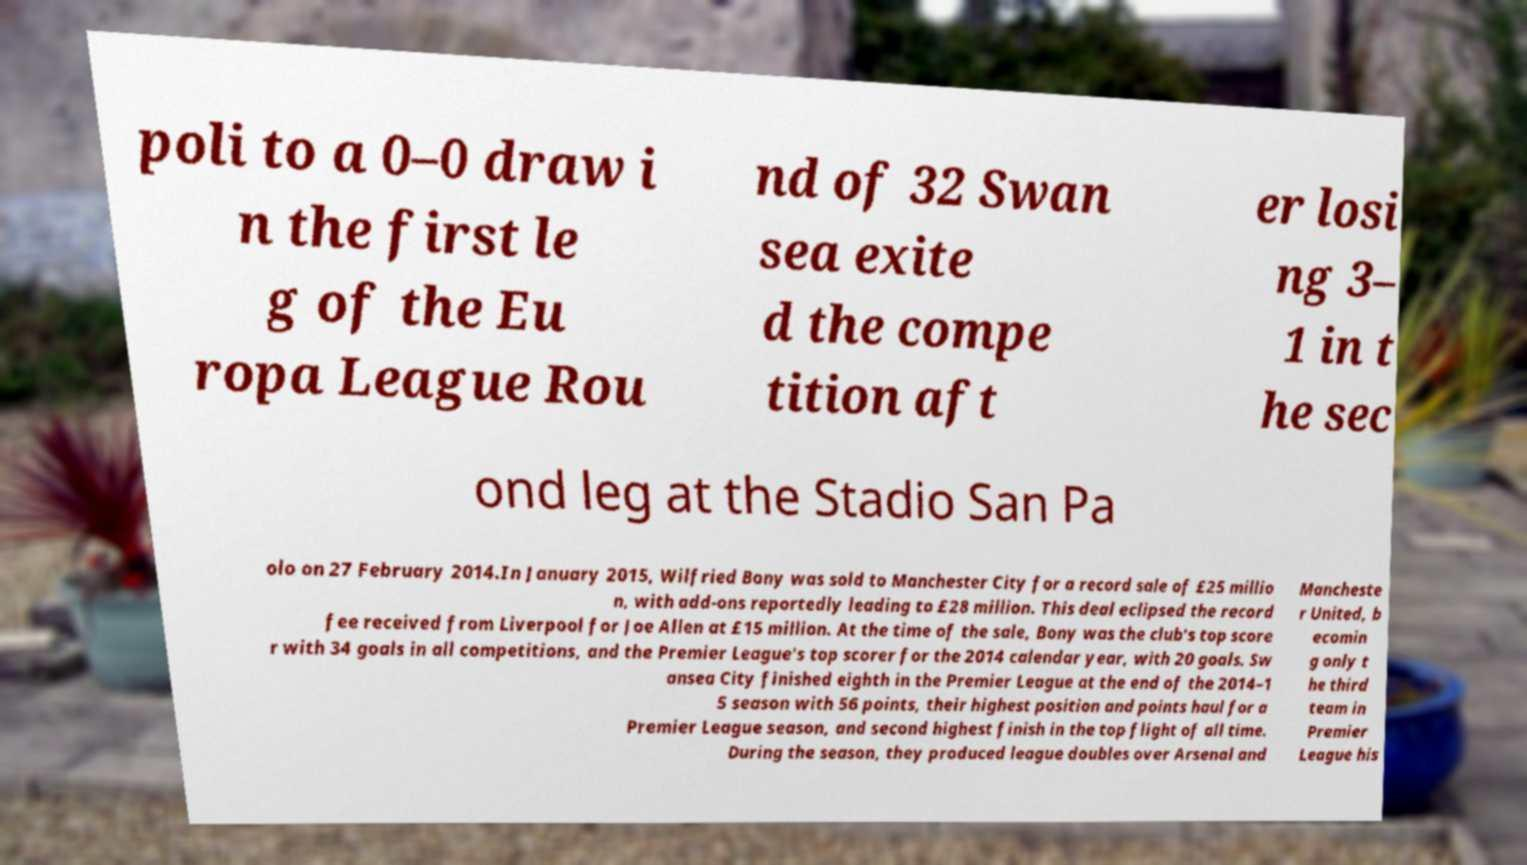Could you extract and type out the text from this image? poli to a 0–0 draw i n the first le g of the Eu ropa League Rou nd of 32 Swan sea exite d the compe tition aft er losi ng 3– 1 in t he sec ond leg at the Stadio San Pa olo on 27 February 2014.In January 2015, Wilfried Bony was sold to Manchester City for a record sale of £25 millio n, with add-ons reportedly leading to £28 million. This deal eclipsed the record fee received from Liverpool for Joe Allen at £15 million. At the time of the sale, Bony was the club's top score r with 34 goals in all competitions, and the Premier League's top scorer for the 2014 calendar year, with 20 goals. Sw ansea City finished eighth in the Premier League at the end of the 2014–1 5 season with 56 points, their highest position and points haul for a Premier League season, and second highest finish in the top flight of all time. During the season, they produced league doubles over Arsenal and Mancheste r United, b ecomin g only t he third team in Premier League his 